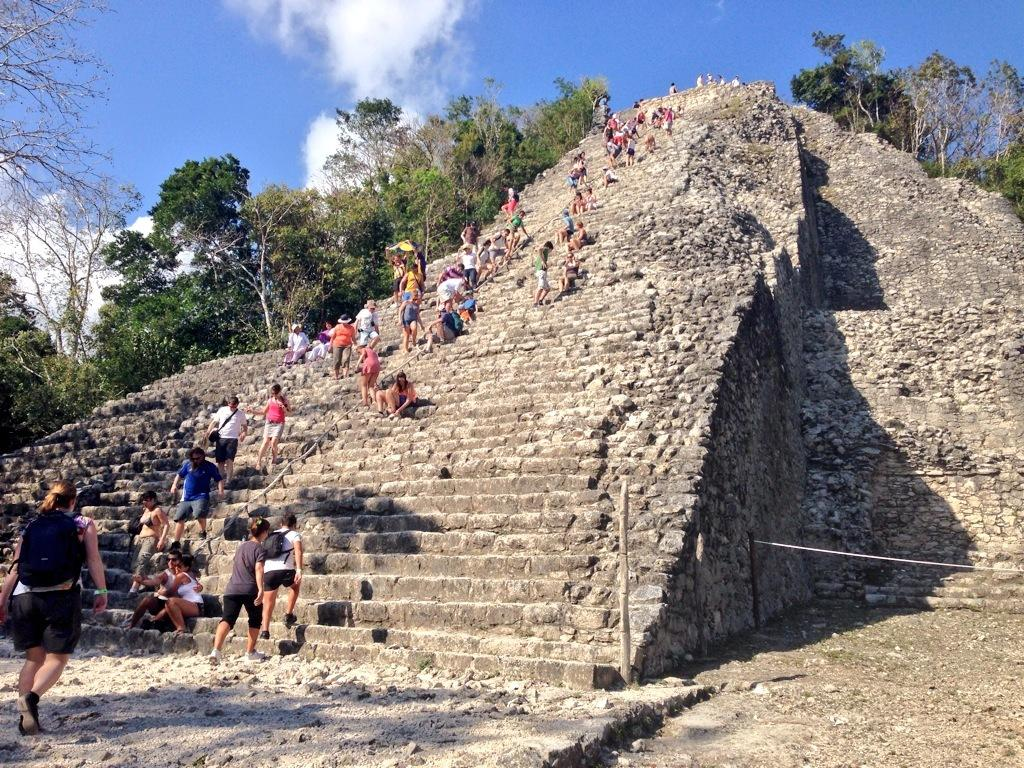How many people are in the image? There are persons in the image, but the exact number is not specified. What are the persons wearing? The persons are wearing clothes. What activity are the persons engaged in? The persons are climbing steps on a hill. What can be seen in the middle of the image? There are trees in the middle of the image. What is visible at the top of the image? There is a sky visible at the top of the image. What type of chain can be seen connecting the persons in the image? There is no chain present in the image; the persons are climbing steps independently. What is the limit of the hill in the image? The facts do not provide information about the size or extent of the hill, so it is not possible to determine its limit. 